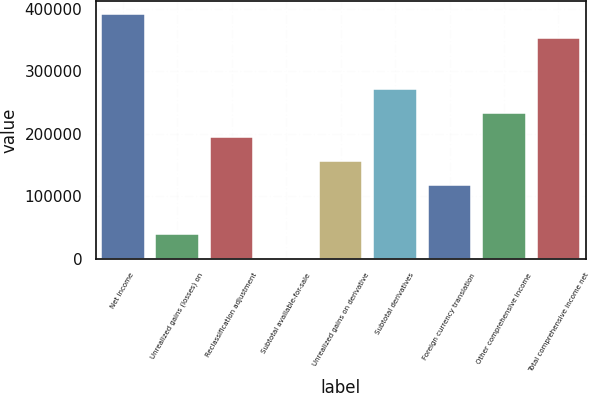Convert chart. <chart><loc_0><loc_0><loc_500><loc_500><bar_chart><fcel>Net income<fcel>Unrealized gains (losses) on<fcel>Reclassification adjustment<fcel>Subtotal available-for-sale<fcel>Unrealized gains on derivative<fcel>Subtotal derivatives<fcel>Foreign currency translation<fcel>Other comprehensive income<fcel>Total comprehensive income net<nl><fcel>392174<fcel>40532.7<fcel>194300<fcel>2091<fcel>155858<fcel>271183<fcel>117416<fcel>232741<fcel>353732<nl></chart> 